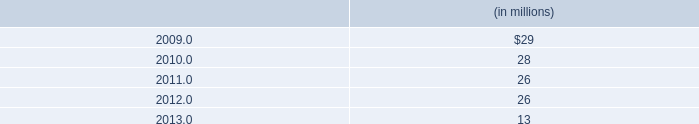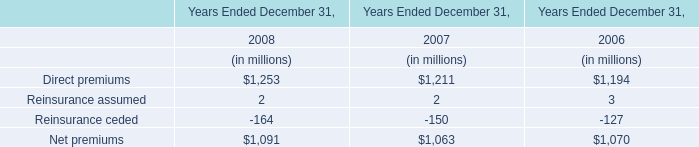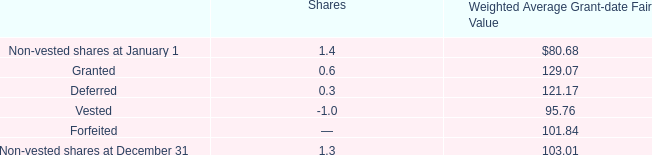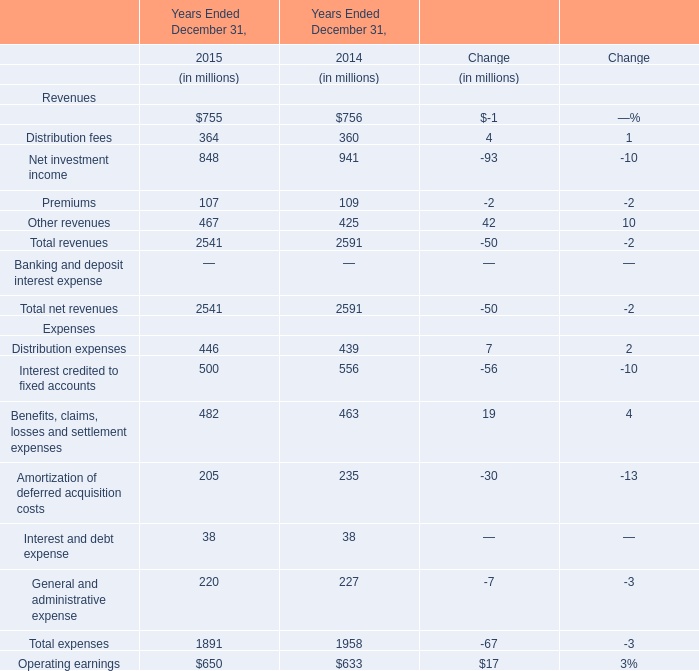What is the difference between the greatest Net investment income in 2014 and 2015？ (in million) 
Computations: (941 - 848)
Answer: 93.0. 